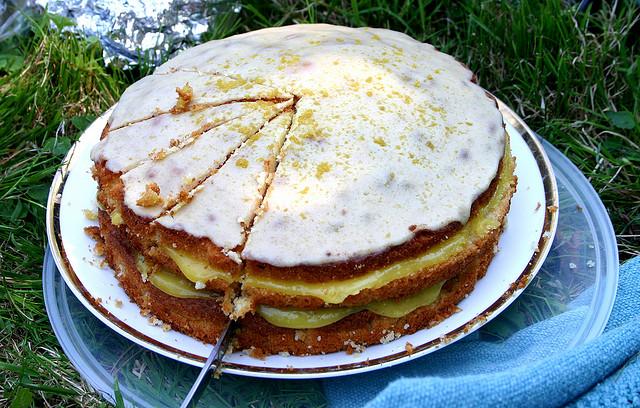Is this plate sitting indoors or outdoors?
Quick response, please. Outdoors. Is the pie eaten?
Be succinct. No. Is that a pie?
Answer briefly. No. 